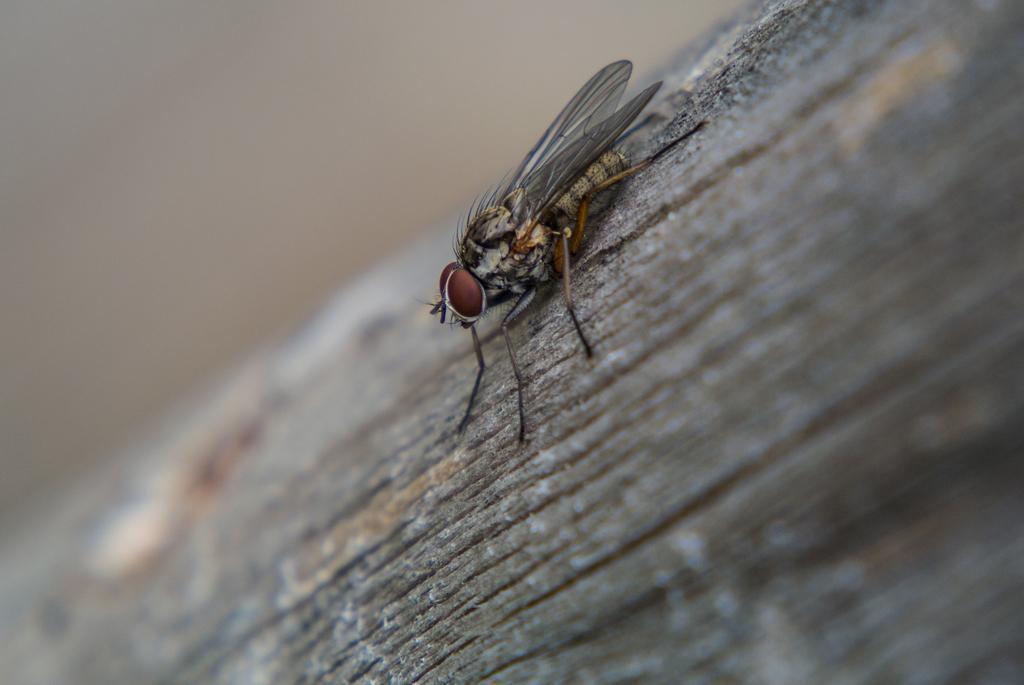Could you give a brief overview of what you see in this image? In this picture we can see a house fly here, we can see a blurry background. 